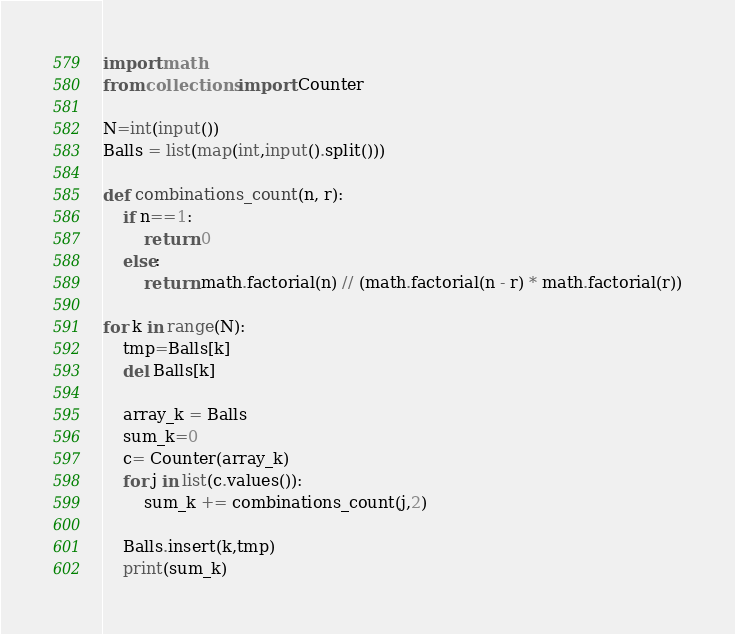Convert code to text. <code><loc_0><loc_0><loc_500><loc_500><_Python_>import math
from collections import Counter

N=int(input())
Balls = list(map(int,input().split()))

def combinations_count(n, r):
    if n==1:
        return 0
    else:
        return math.factorial(n) // (math.factorial(n - r) * math.factorial(r))

for k in range(N):
    tmp=Balls[k]
    del Balls[k]

    array_k = Balls
    sum_k=0
    c= Counter(array_k)
    for j in list(c.values()):
        sum_k += combinations_count(j,2)
    
    Balls.insert(k,tmp)
    print(sum_k)


</code> 